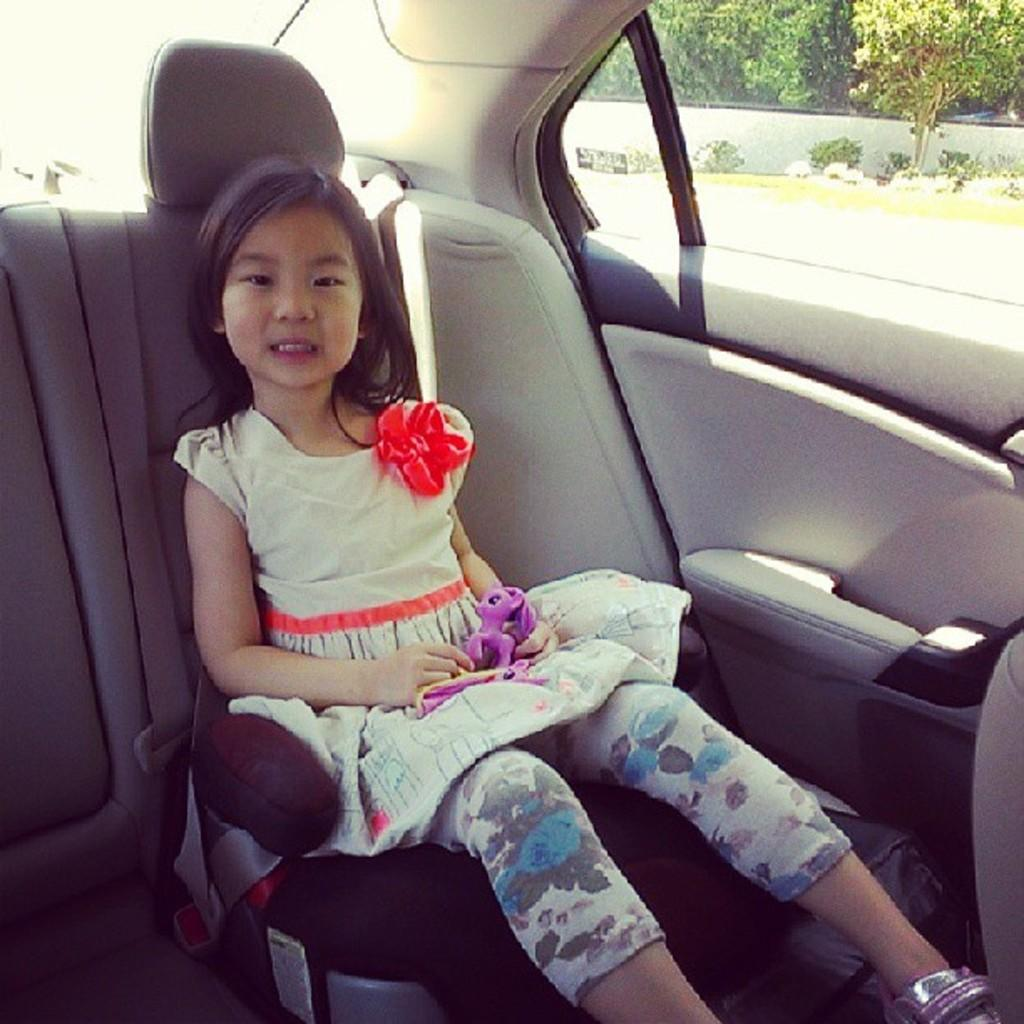What is the girl doing in the image? The girl is sitting on the seat in the car. What can be seen in the background of the image? There are trees visible in the background of the image. What type of music is the girl listening to in the car? The image does not provide any information about the girl listening to music, so we cannot determine what type of music she might be listening to. 